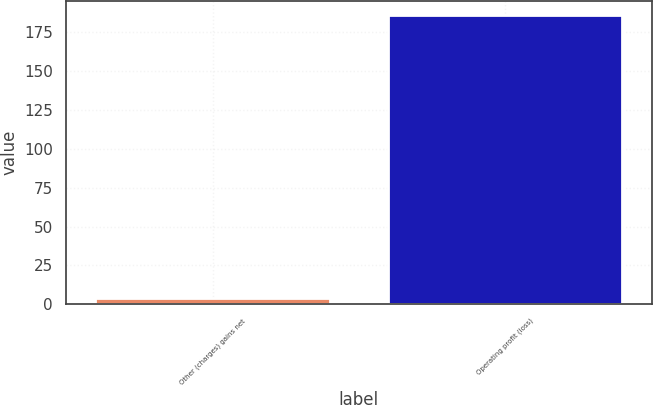<chart> <loc_0><loc_0><loc_500><loc_500><bar_chart><fcel>Other (charges) gains net<fcel>Operating profit (loss)<nl><fcel>4<fcel>186<nl></chart> 